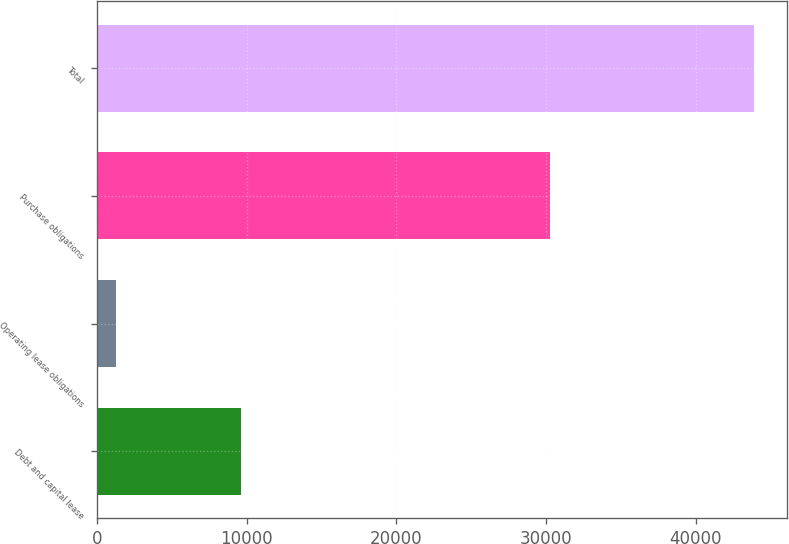Convert chart. <chart><loc_0><loc_0><loc_500><loc_500><bar_chart><fcel>Debt and capital lease<fcel>Operating lease obligations<fcel>Purchase obligations<fcel>Total<nl><fcel>9621<fcel>1287<fcel>30225<fcel>43862<nl></chart> 